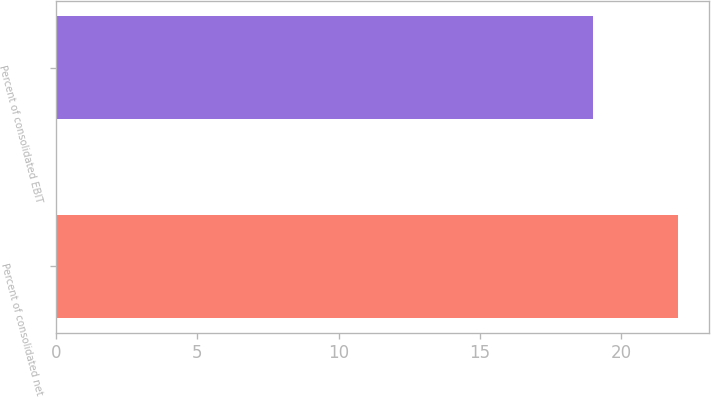Convert chart to OTSL. <chart><loc_0><loc_0><loc_500><loc_500><bar_chart><fcel>Percent of consolidated net<fcel>Percent of consolidated EBIT<nl><fcel>22<fcel>19<nl></chart> 